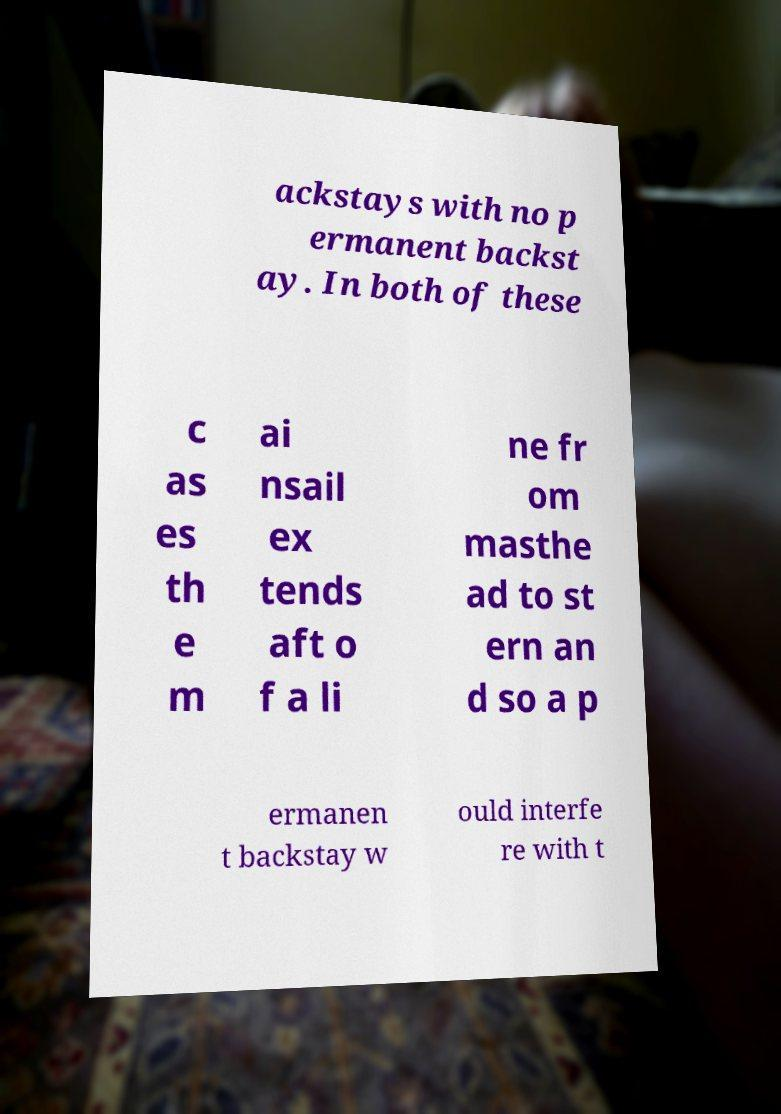Could you extract and type out the text from this image? ackstays with no p ermanent backst ay. In both of these c as es th e m ai nsail ex tends aft o f a li ne fr om masthe ad to st ern an d so a p ermanen t backstay w ould interfe re with t 